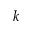Convert formula to latex. <formula><loc_0><loc_0><loc_500><loc_500>{ k }</formula> 